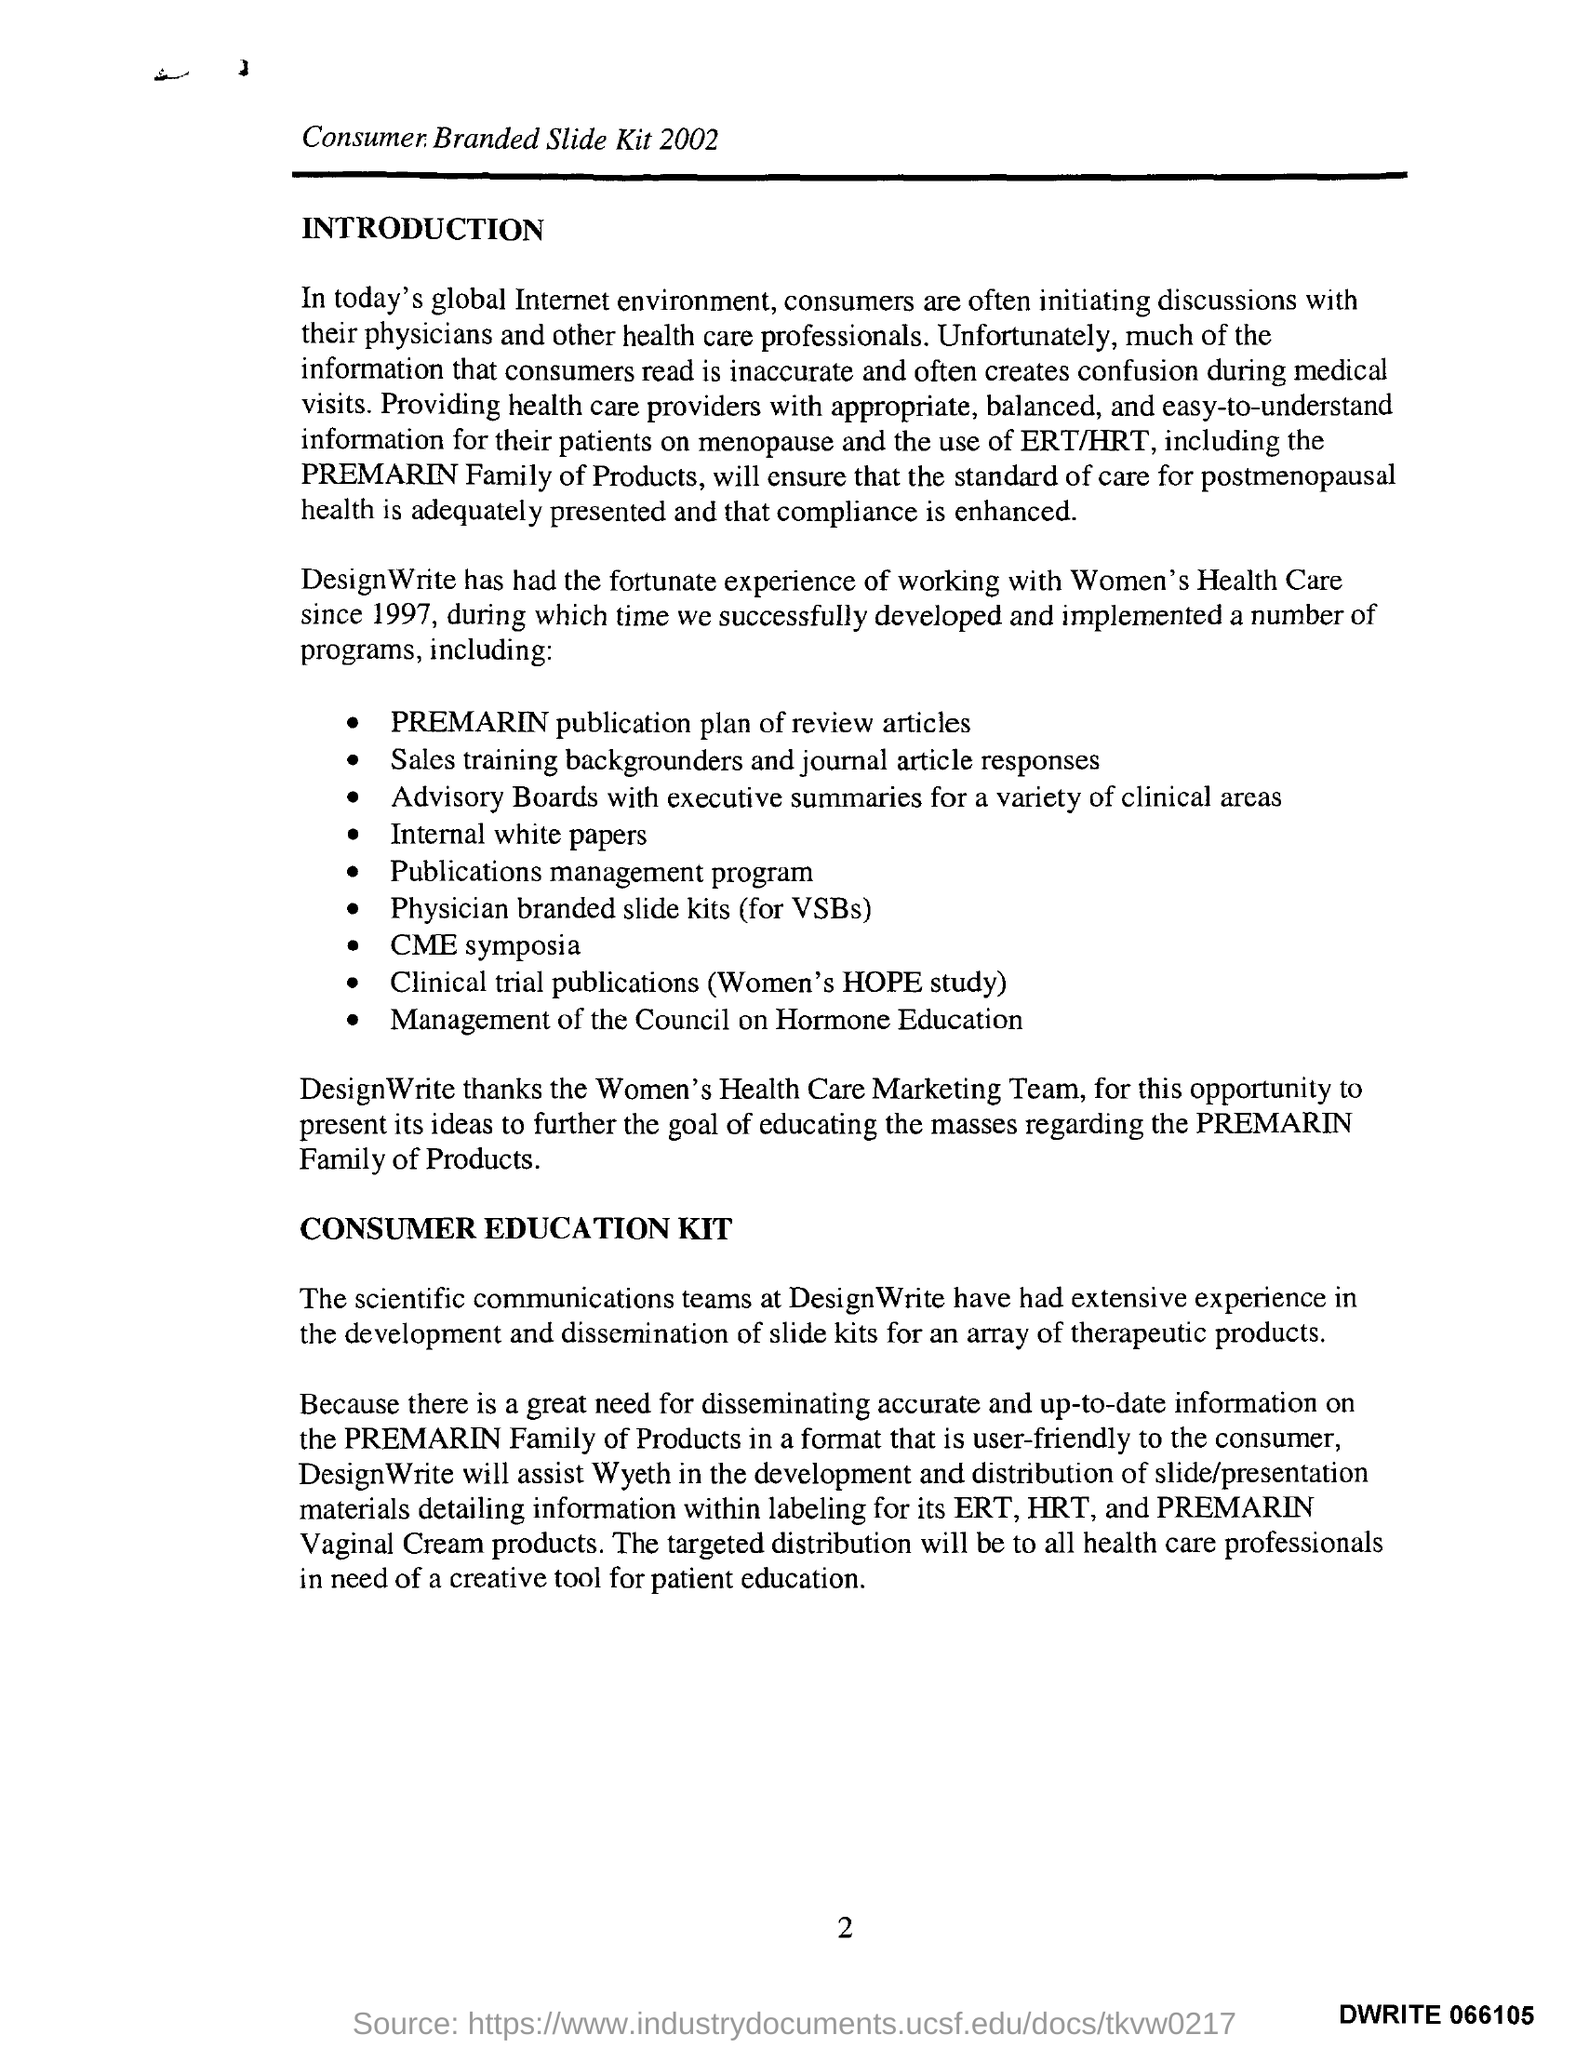Indicate a few pertinent items in this graphic. The second title below the line is 'Consumer Education Kit.' The title of the document above the line is 'Consumer Branded slide Kit 2002'. The first title below the line is 'Introduction.' The page number is 2, as declared. 